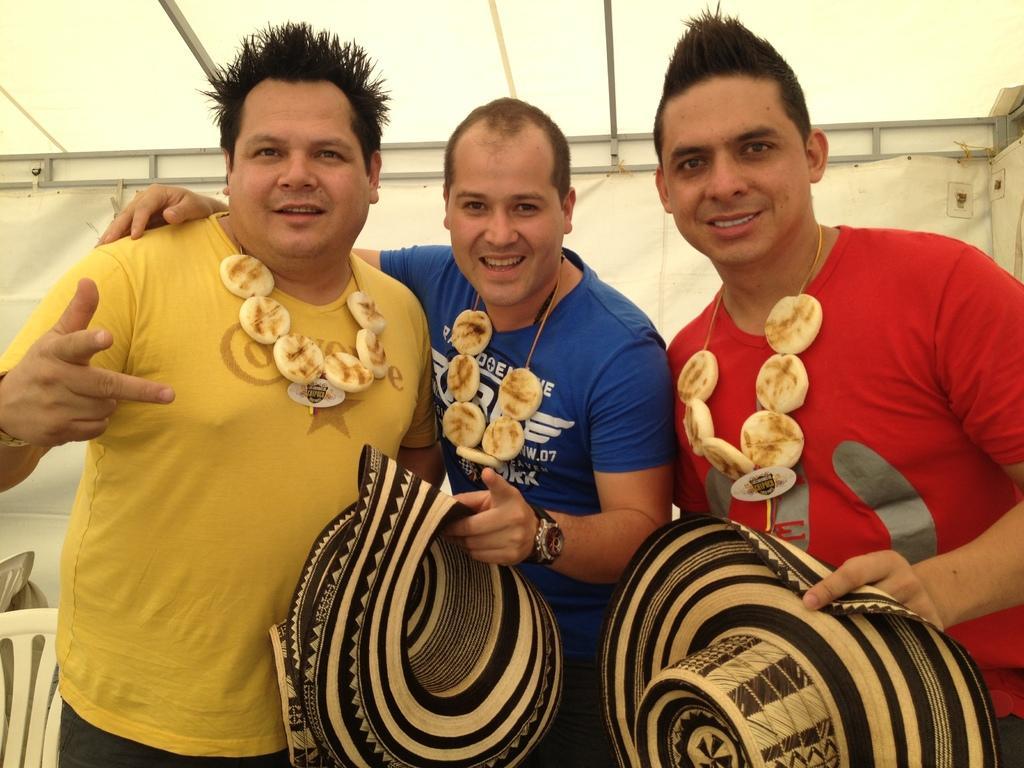Please provide a concise description of this image. In this image I can see three men are wearing t-shirts, standing, smiling and giving pose for the picture. I can see two men are holding caps in their hands. In the background there is a wall and some chairs. 